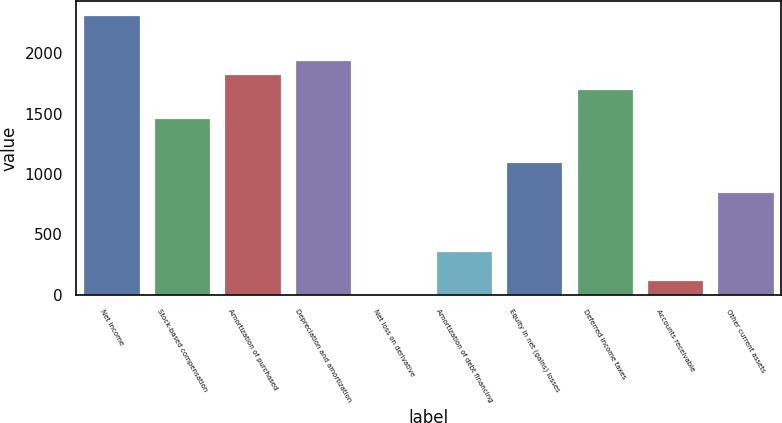<chart> <loc_0><loc_0><loc_500><loc_500><bar_chart><fcel>Net income<fcel>Stock-based compensation<fcel>Amortization of purchased<fcel>Depreciation and amortization<fcel>Net loss on derivative<fcel>Amortization of debt financing<fcel>Equity in net (gains) losses<fcel>Deferred income taxes<fcel>Accounts receivable<fcel>Other current assets<nl><fcel>2311.83<fcel>1460.14<fcel>1825.15<fcel>1946.82<fcel>0.1<fcel>365.11<fcel>1095.13<fcel>1703.48<fcel>121.77<fcel>851.79<nl></chart> 